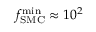<formula> <loc_0><loc_0><loc_500><loc_500>f _ { S M C } ^ { \min } \approx 1 0 ^ { 2 }</formula> 